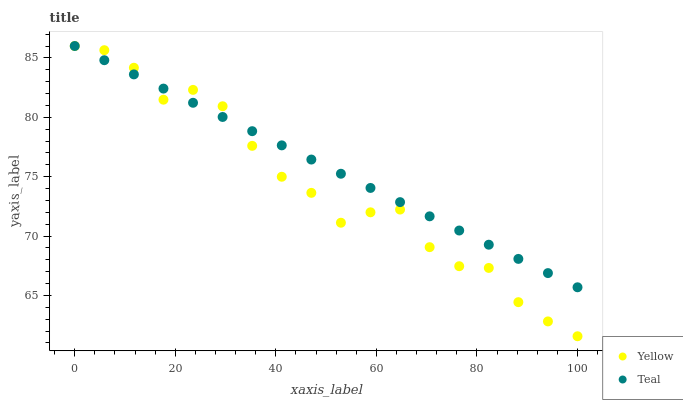Does Yellow have the minimum area under the curve?
Answer yes or no. Yes. Does Teal have the maximum area under the curve?
Answer yes or no. Yes. Does Yellow have the maximum area under the curve?
Answer yes or no. No. Is Teal the smoothest?
Answer yes or no. Yes. Is Yellow the roughest?
Answer yes or no. Yes. Is Yellow the smoothest?
Answer yes or no. No. Does Yellow have the lowest value?
Answer yes or no. Yes. Does Yellow have the highest value?
Answer yes or no. Yes. Does Teal intersect Yellow?
Answer yes or no. Yes. Is Teal less than Yellow?
Answer yes or no. No. Is Teal greater than Yellow?
Answer yes or no. No. 